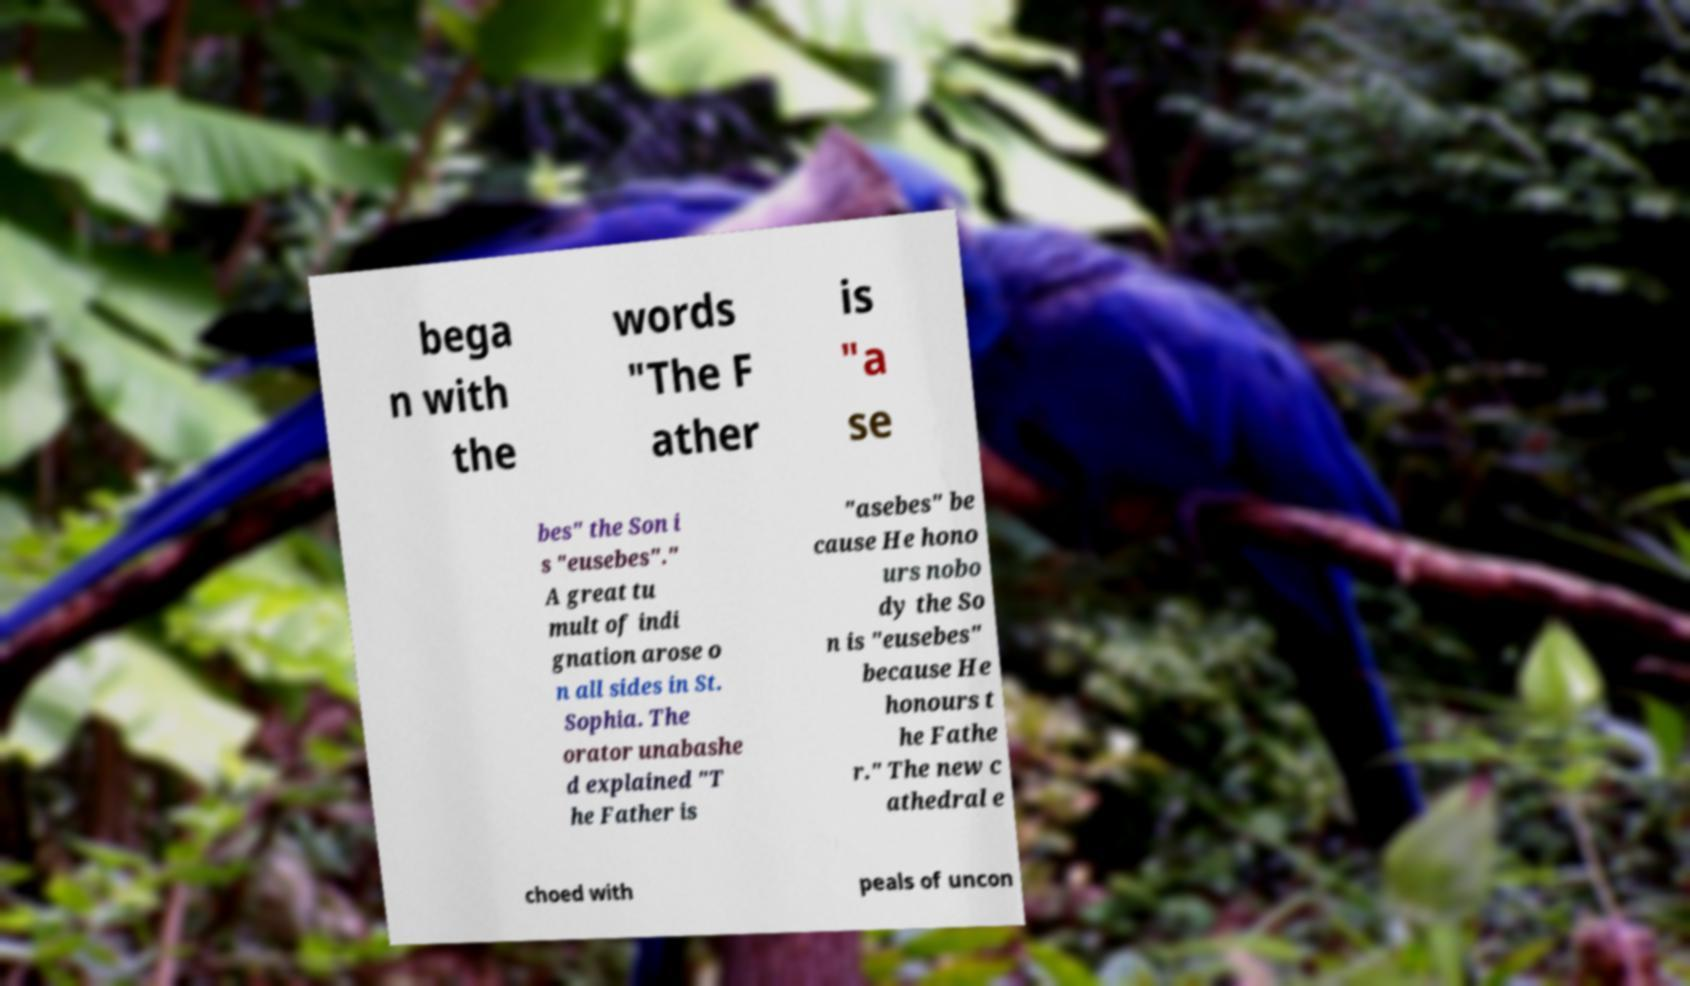Could you assist in decoding the text presented in this image and type it out clearly? bega n with the words "The F ather is "a se bes" the Son i s "eusebes"." A great tu mult of indi gnation arose o n all sides in St. Sophia. The orator unabashe d explained "T he Father is "asebes" be cause He hono urs nobo dy the So n is "eusebes" because He honours t he Fathe r." The new c athedral e choed with peals of uncon 